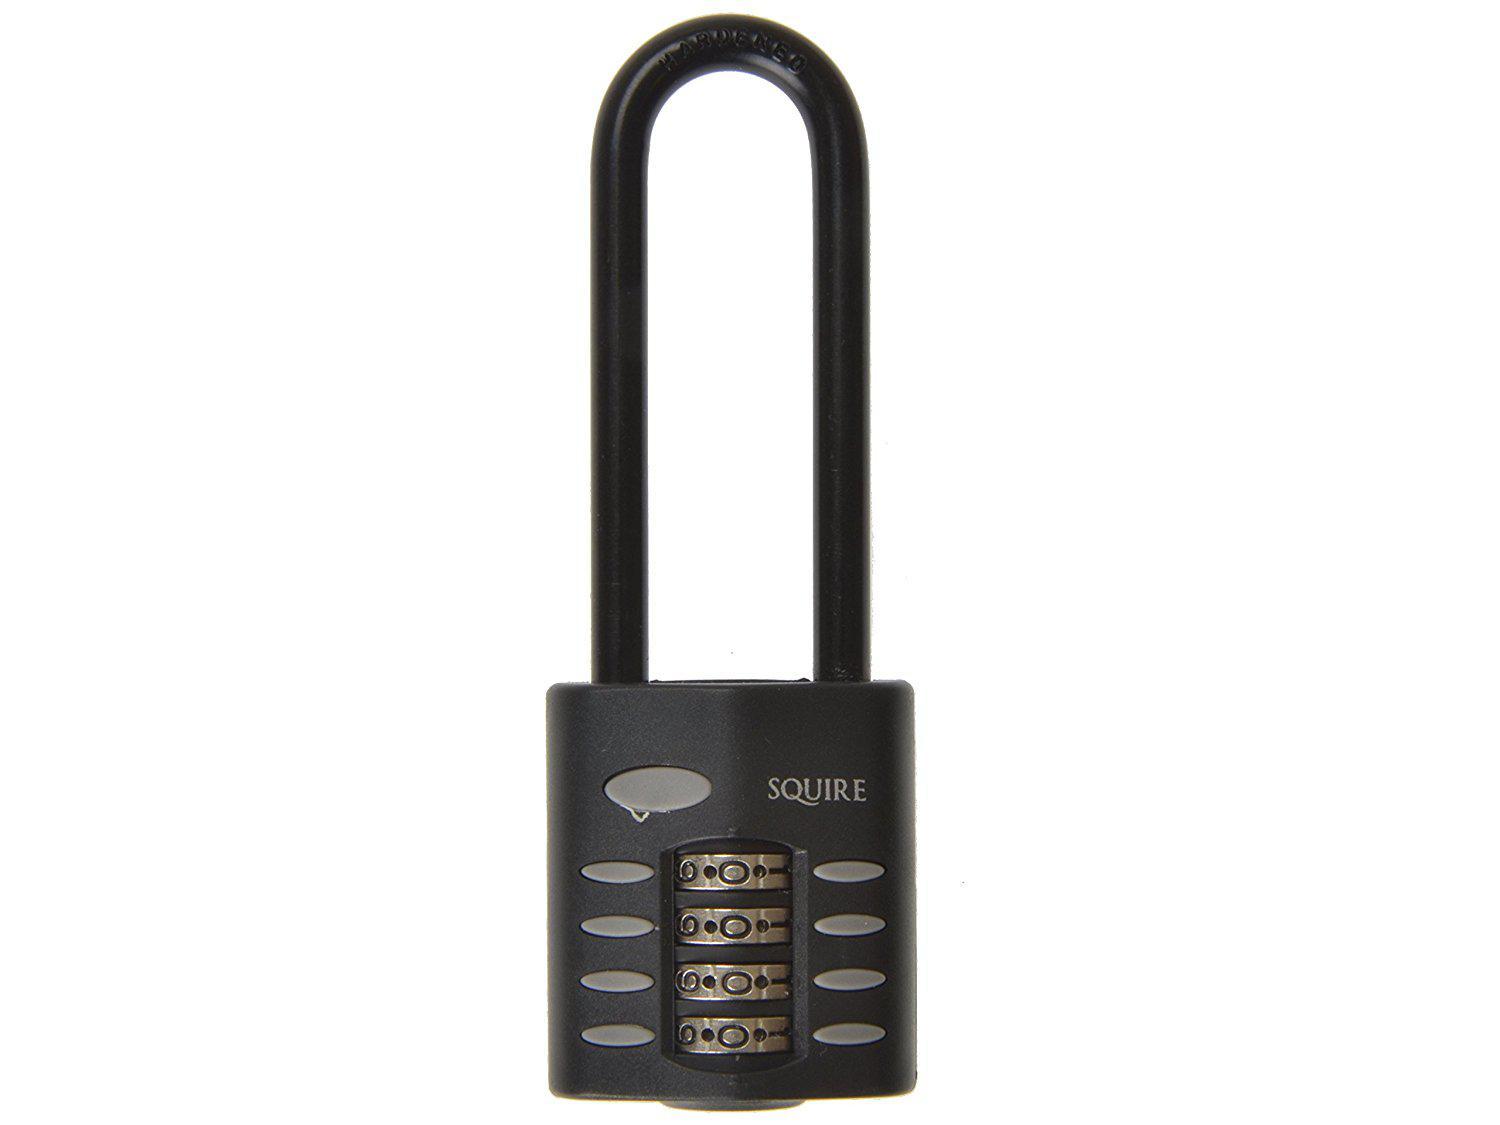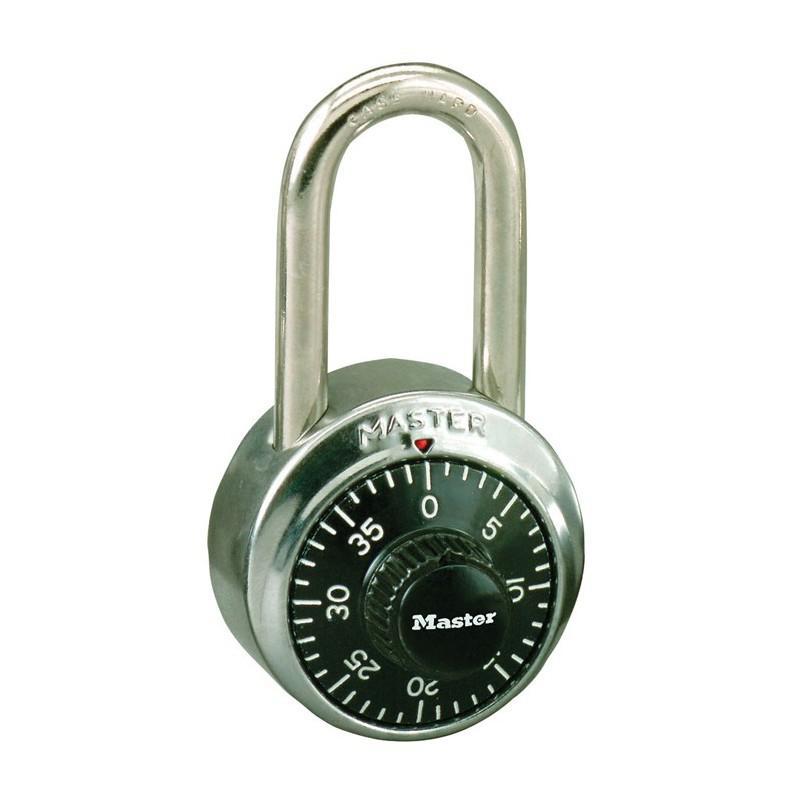The first image is the image on the left, the second image is the image on the right. Analyze the images presented: Is the assertion "One lock is round with a black number dial, which the other is roughly square with four scrolling number belts." valid? Answer yes or no. Yes. The first image is the image on the left, the second image is the image on the right. Assess this claim about the two images: "One of the locks is round in shape.". Correct or not? Answer yes or no. Yes. 